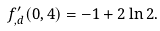<formula> <loc_0><loc_0><loc_500><loc_500>f ^ { \prime } _ { , d } ( 0 , 4 ) = - 1 + 2 \ln 2 .</formula> 